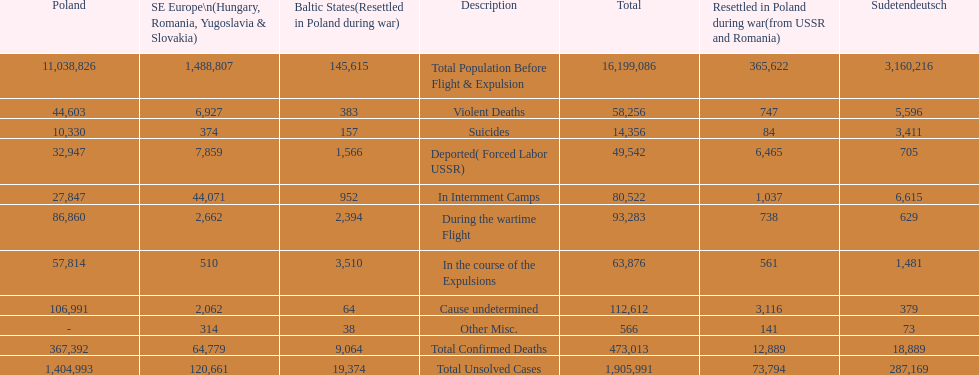What is the total of deaths in internment camps and during the wartime flight? 173,805. 